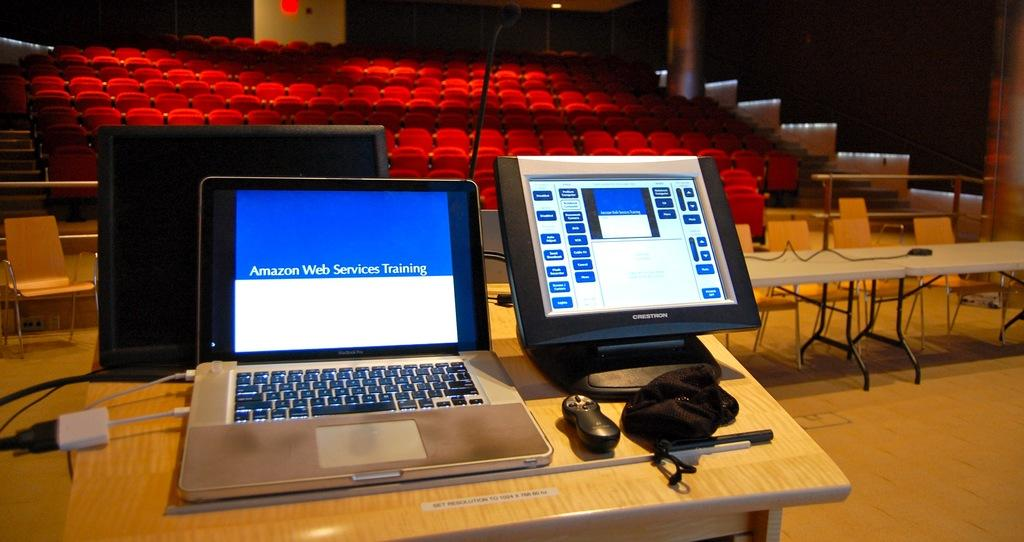What electronic device can be seen in the image? There is a laptop and a monitor in the image. What object is used for controlling electronic devices in the image? There is a remote in the image. What material is present in the image for cleaning or covering? There is a cloth in the image. What object is used for pointing or poking in the image? There is a stick in the image. What type of connection is present in the image? There is a cable in the image. What type of entertainment device is present in the image? There is a television in the image. Where are the objects arranged in the image? The objects are arranged on a table. What type of furniture is visible in the background of the image? There are chairs in the background of the image. What other table can be seen in the background of the image? There is another table in the background of the image. What type of lighting is visible in the background of the image? There are lights in the background of the image. What architectural feature is visible in the background of the image? There is a staircase in the background of the image. What type of sail can be seen in the image? There is no sail present in the image. 